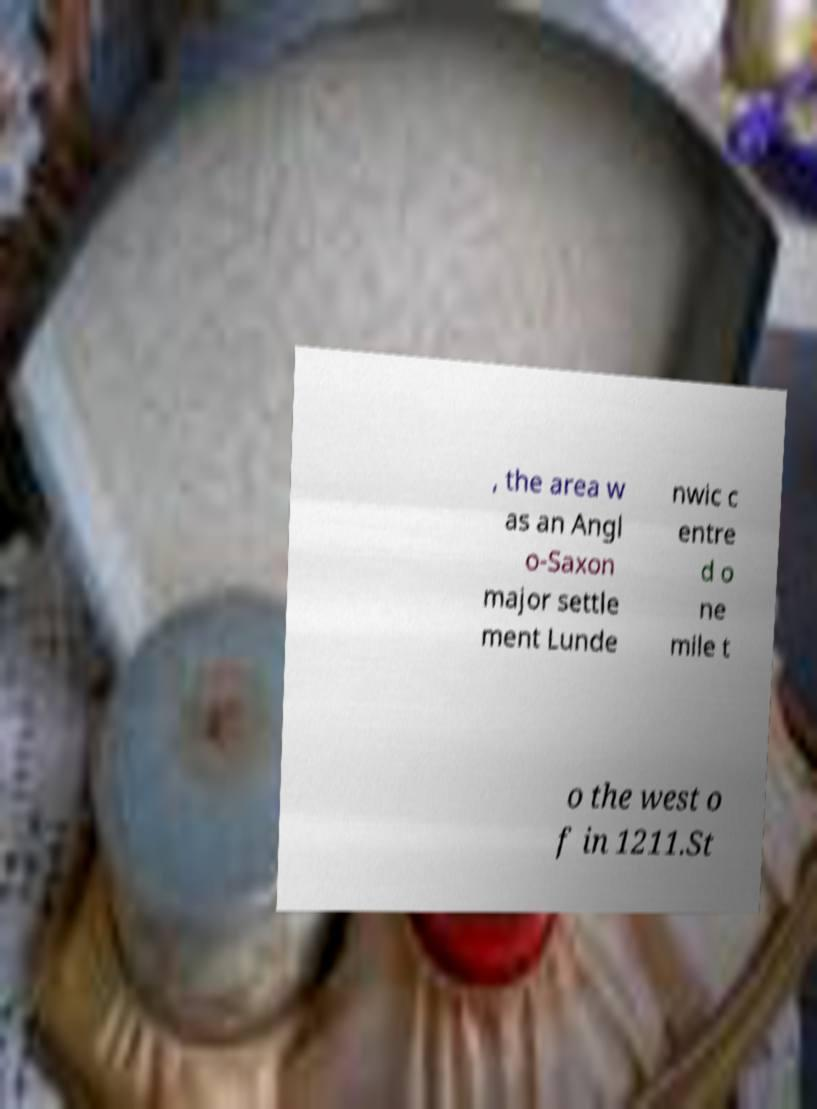For documentation purposes, I need the text within this image transcribed. Could you provide that? , the area w as an Angl o-Saxon major settle ment Lunde nwic c entre d o ne mile t o the west o f in 1211.St 